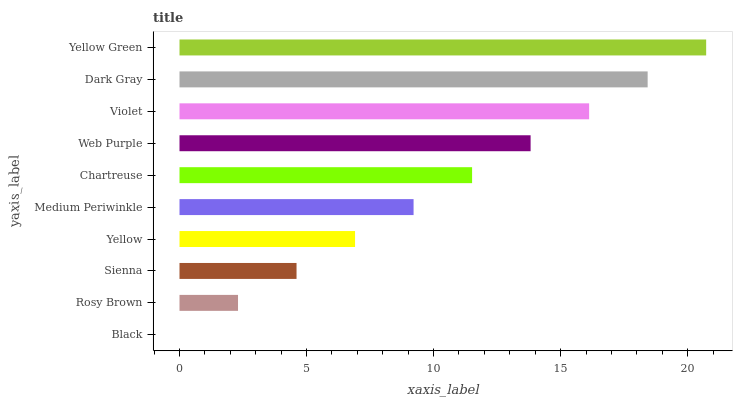Is Black the minimum?
Answer yes or no. Yes. Is Yellow Green the maximum?
Answer yes or no. Yes. Is Rosy Brown the minimum?
Answer yes or no. No. Is Rosy Brown the maximum?
Answer yes or no. No. Is Rosy Brown greater than Black?
Answer yes or no. Yes. Is Black less than Rosy Brown?
Answer yes or no. Yes. Is Black greater than Rosy Brown?
Answer yes or no. No. Is Rosy Brown less than Black?
Answer yes or no. No. Is Chartreuse the high median?
Answer yes or no. Yes. Is Medium Periwinkle the low median?
Answer yes or no. Yes. Is Medium Periwinkle the high median?
Answer yes or no. No. Is Violet the low median?
Answer yes or no. No. 